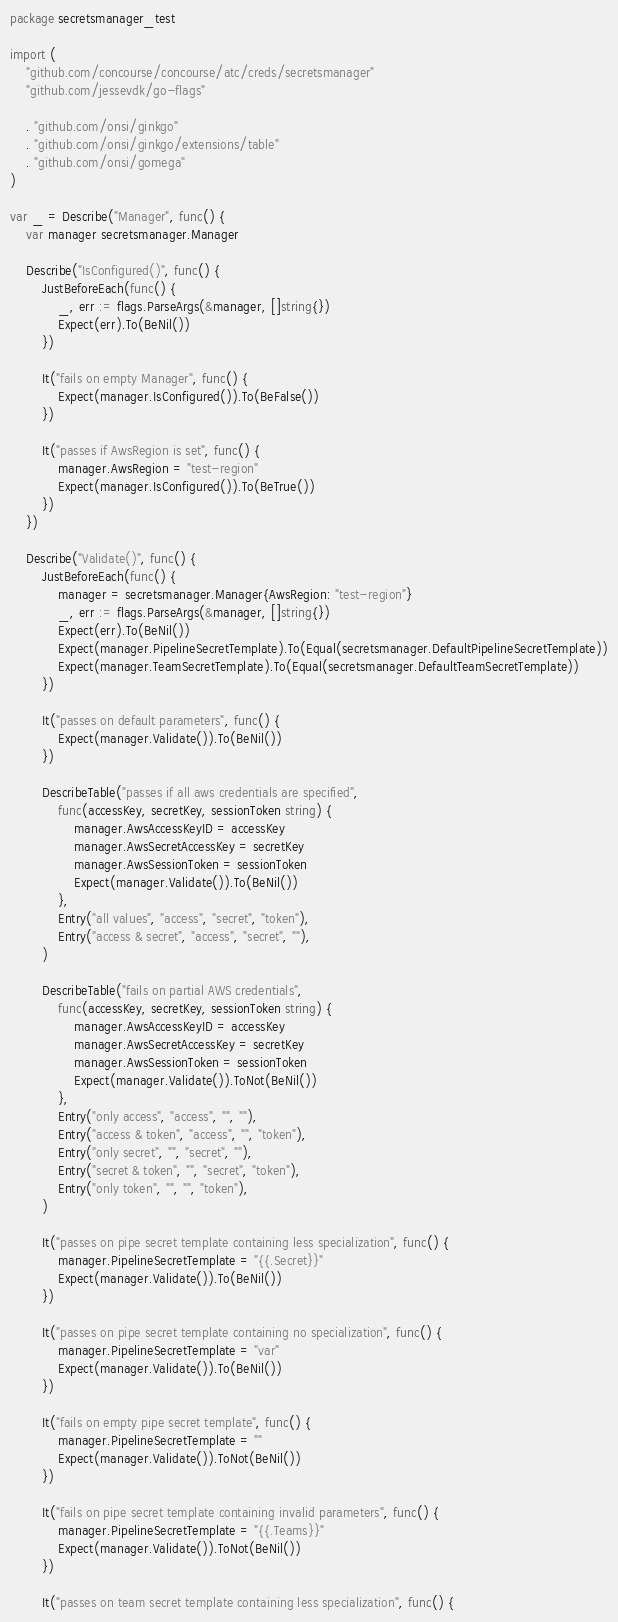Convert code to text. <code><loc_0><loc_0><loc_500><loc_500><_Go_>package secretsmanager_test

import (
	"github.com/concourse/concourse/atc/creds/secretsmanager"
	"github.com/jessevdk/go-flags"

	. "github.com/onsi/ginkgo"
	. "github.com/onsi/ginkgo/extensions/table"
	. "github.com/onsi/gomega"
)

var _ = Describe("Manager", func() {
	var manager secretsmanager.Manager

	Describe("IsConfigured()", func() {
		JustBeforeEach(func() {
			_, err := flags.ParseArgs(&manager, []string{})
			Expect(err).To(BeNil())
		})

		It("fails on empty Manager", func() {
			Expect(manager.IsConfigured()).To(BeFalse())
		})

		It("passes if AwsRegion is set", func() {
			manager.AwsRegion = "test-region"
			Expect(manager.IsConfigured()).To(BeTrue())
		})
	})

	Describe("Validate()", func() {
		JustBeforeEach(func() {
			manager = secretsmanager.Manager{AwsRegion: "test-region"}
			_, err := flags.ParseArgs(&manager, []string{})
			Expect(err).To(BeNil())
			Expect(manager.PipelineSecretTemplate).To(Equal(secretsmanager.DefaultPipelineSecretTemplate))
			Expect(manager.TeamSecretTemplate).To(Equal(secretsmanager.DefaultTeamSecretTemplate))
		})

		It("passes on default parameters", func() {
			Expect(manager.Validate()).To(BeNil())
		})

		DescribeTable("passes if all aws credentials are specified",
			func(accessKey, secretKey, sessionToken string) {
				manager.AwsAccessKeyID = accessKey
				manager.AwsSecretAccessKey = secretKey
				manager.AwsSessionToken = sessionToken
				Expect(manager.Validate()).To(BeNil())
			},
			Entry("all values", "access", "secret", "token"),
			Entry("access & secret", "access", "secret", ""),
		)

		DescribeTable("fails on partial AWS credentials",
			func(accessKey, secretKey, sessionToken string) {
				manager.AwsAccessKeyID = accessKey
				manager.AwsSecretAccessKey = secretKey
				manager.AwsSessionToken = sessionToken
				Expect(manager.Validate()).ToNot(BeNil())
			},
			Entry("only access", "access", "", ""),
			Entry("access & token", "access", "", "token"),
			Entry("only secret", "", "secret", ""),
			Entry("secret & token", "", "secret", "token"),
			Entry("only token", "", "", "token"),
		)

		It("passes on pipe secret template containing less specialization", func() {
			manager.PipelineSecretTemplate = "{{.Secret}}"
			Expect(manager.Validate()).To(BeNil())
		})

		It("passes on pipe secret template containing no specialization", func() {
			manager.PipelineSecretTemplate = "var"
			Expect(manager.Validate()).To(BeNil())
		})

		It("fails on empty pipe secret template", func() {
			manager.PipelineSecretTemplate = ""
			Expect(manager.Validate()).ToNot(BeNil())
		})

		It("fails on pipe secret template containing invalid parameters", func() {
			manager.PipelineSecretTemplate = "{{.Teams}}"
			Expect(manager.Validate()).ToNot(BeNil())
		})

		It("passes on team secret template containing less specialization", func() {</code> 